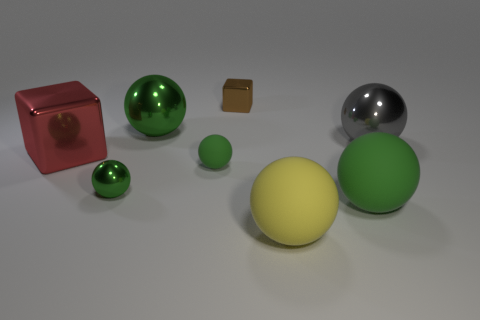What number of cubes are the same color as the tiny rubber sphere?
Ensure brevity in your answer.  0. What number of objects are large spheres that are behind the big red thing or tiny red objects?
Offer a terse response. 2. There is a tiny sphere that is the same material as the large cube; what is its color?
Offer a very short reply. Green. Is there another object of the same size as the red metal thing?
Ensure brevity in your answer.  Yes. What number of things are either yellow matte objects right of the small matte thing or things on the right side of the large yellow sphere?
Offer a very short reply. 3. The green metallic thing that is the same size as the gray metal thing is what shape?
Offer a terse response. Sphere. Are there any tiny red metallic objects of the same shape as the big red metal object?
Ensure brevity in your answer.  No. Are there fewer big green shiny things than large yellow cubes?
Make the answer very short. No. Do the metallic block on the left side of the brown shiny block and the sphere that is in front of the big green matte sphere have the same size?
Ensure brevity in your answer.  Yes. What number of objects are red rubber objects or yellow rubber balls?
Your response must be concise. 1. 